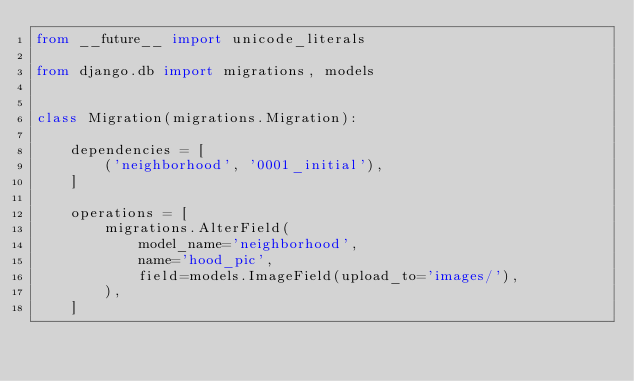Convert code to text. <code><loc_0><loc_0><loc_500><loc_500><_Python_>from __future__ import unicode_literals

from django.db import migrations, models


class Migration(migrations.Migration):

    dependencies = [
        ('neighborhood', '0001_initial'),
    ]

    operations = [
        migrations.AlterField(
            model_name='neighborhood',
            name='hood_pic',
            field=models.ImageField(upload_to='images/'),
        ),
    ]
</code> 